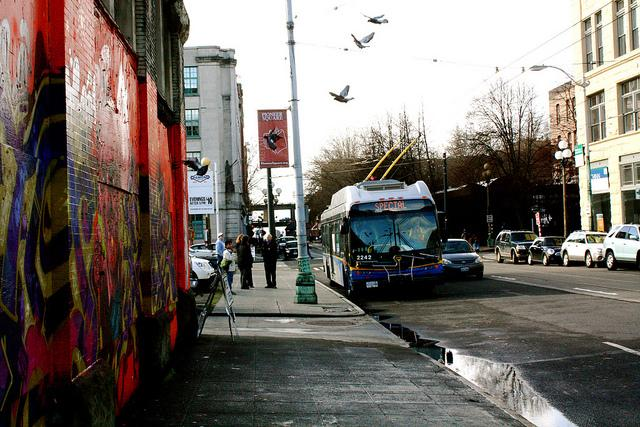What color are the birds flying over the street? grey 